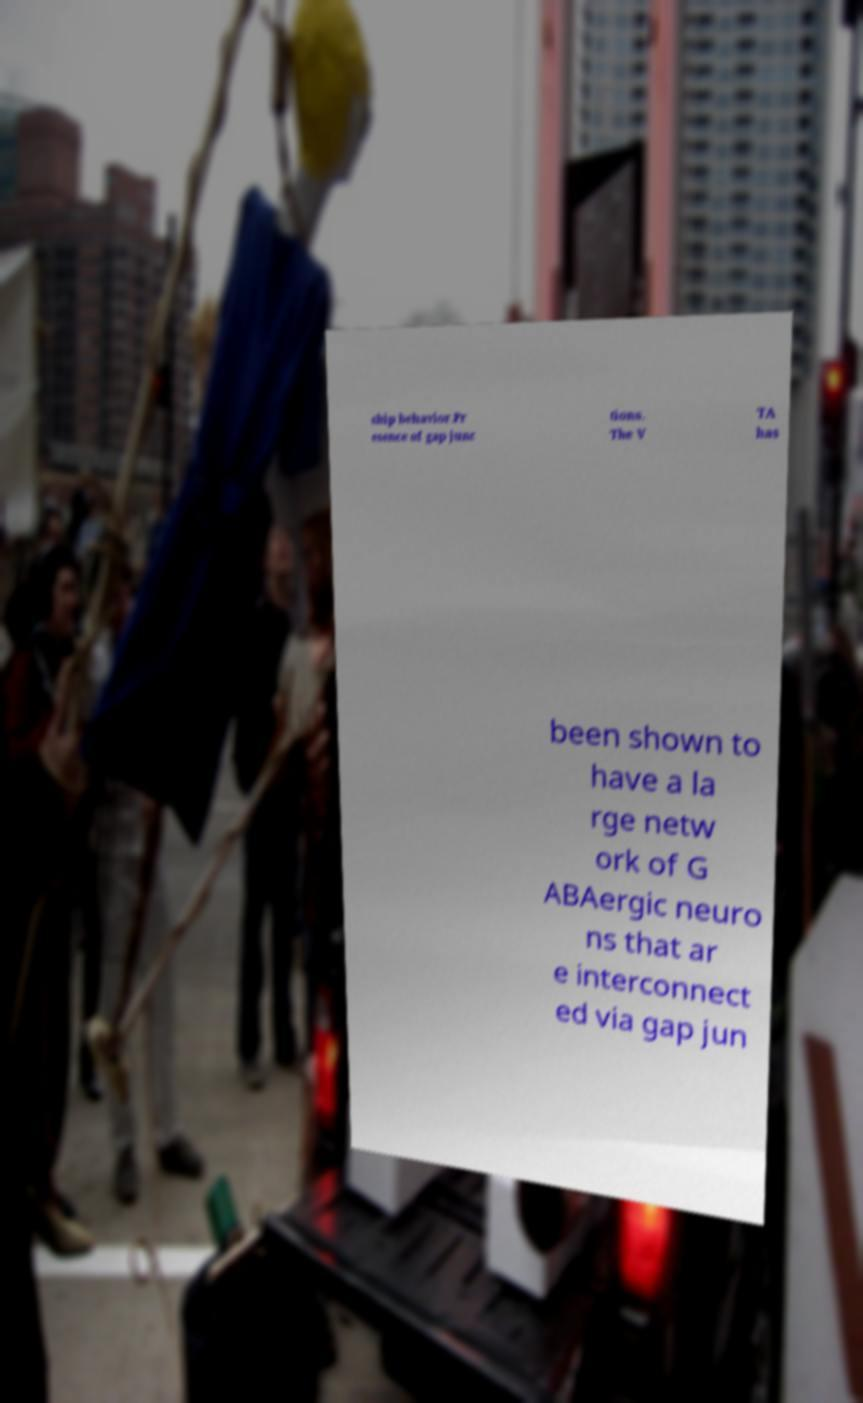Could you extract and type out the text from this image? ship behavior.Pr esence of gap junc tions. The V TA has been shown to have a la rge netw ork of G ABAergic neuro ns that ar e interconnect ed via gap jun 